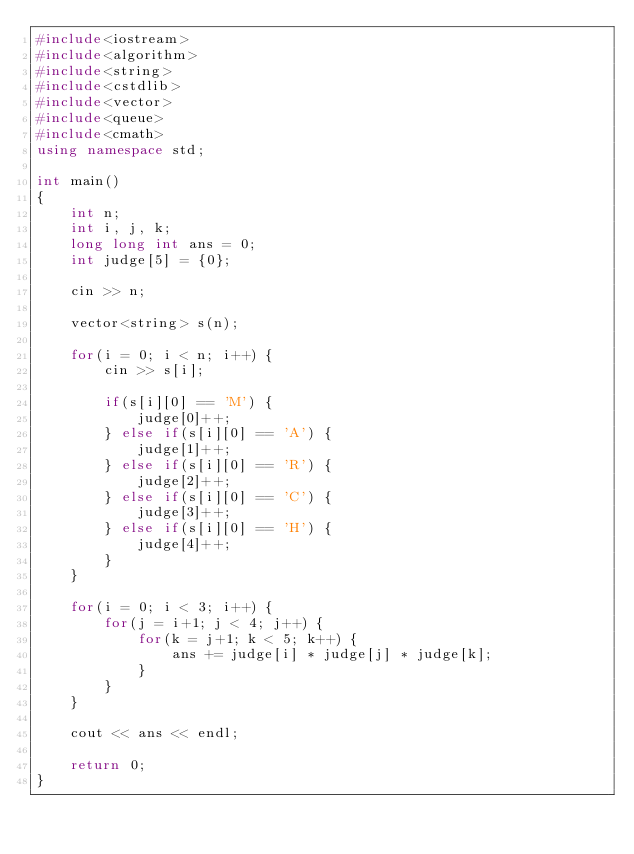<code> <loc_0><loc_0><loc_500><loc_500><_C++_>#include<iostream>
#include<algorithm>
#include<string>
#include<cstdlib>
#include<vector>
#include<queue>
#include<cmath>
using namespace std;

int main()
{
    int n;
    int i, j, k;
    long long int ans = 0;
    int judge[5] = {0};
    
    cin >> n;
    
    vector<string> s(n);
    
    for(i = 0; i < n; i++) {
        cin >> s[i];
        
        if(s[i][0] == 'M') {
            judge[0]++;
        } else if(s[i][0] == 'A') {
            judge[1]++;
        } else if(s[i][0] == 'R') {
            judge[2]++;
        } else if(s[i][0] == 'C') {
            judge[3]++;
        } else if(s[i][0] == 'H') {
            judge[4]++;
        }
    }
    
    for(i = 0; i < 3; i++) {
        for(j = i+1; j < 4; j++) {
            for(k = j+1; k < 5; k++) {
                ans += judge[i] * judge[j] * judge[k];
            }
        }
    }
    
    cout << ans << endl;
    
    return 0;
}</code> 